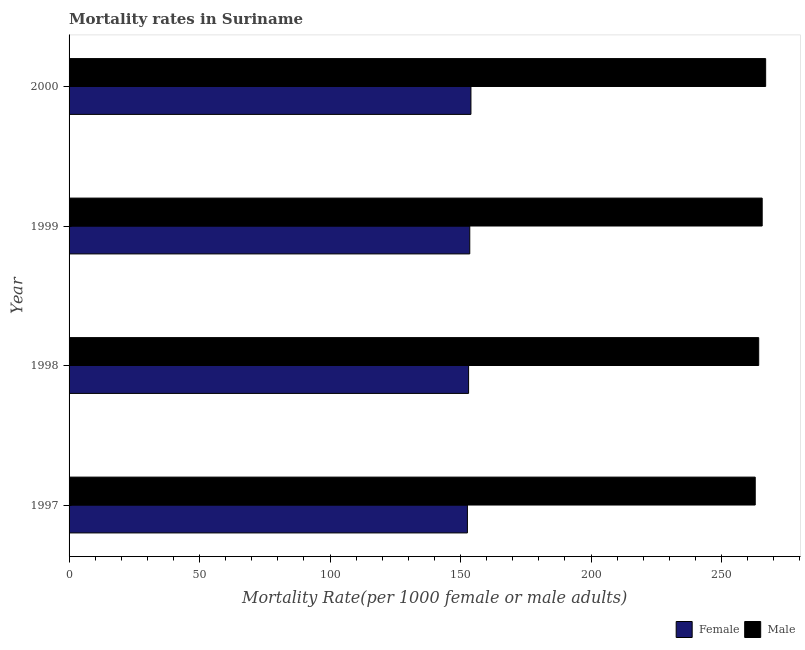How many different coloured bars are there?
Make the answer very short. 2. How many bars are there on the 1st tick from the bottom?
Give a very brief answer. 2. What is the female mortality rate in 1997?
Make the answer very short. 152.63. Across all years, what is the maximum male mortality rate?
Provide a succinct answer. 266.91. Across all years, what is the minimum male mortality rate?
Give a very brief answer. 262.92. In which year was the female mortality rate maximum?
Your answer should be compact. 2000. What is the total female mortality rate in the graph?
Offer a terse response. 613.24. What is the difference between the male mortality rate in 1997 and that in 2000?
Your response must be concise. -4. What is the difference between the female mortality rate in 1999 and the male mortality rate in 2000?
Give a very brief answer. -113.38. What is the average male mortality rate per year?
Your answer should be compact. 264.92. In the year 1999, what is the difference between the male mortality rate and female mortality rate?
Keep it short and to the point. 112.05. In how many years, is the male mortality rate greater than 260 ?
Offer a very short reply. 4. Is the difference between the male mortality rate in 1998 and 1999 greater than the difference between the female mortality rate in 1998 and 1999?
Your answer should be compact. No. What is the difference between the highest and the second highest female mortality rate?
Make the answer very short. 0.45. What is the difference between the highest and the lowest female mortality rate?
Your response must be concise. 1.35. What does the 1st bar from the top in 1999 represents?
Your response must be concise. Male. How many bars are there?
Offer a terse response. 8. What is the difference between two consecutive major ticks on the X-axis?
Offer a very short reply. 50. Are the values on the major ticks of X-axis written in scientific E-notation?
Give a very brief answer. No. Does the graph contain any zero values?
Keep it short and to the point. No. How are the legend labels stacked?
Offer a terse response. Horizontal. What is the title of the graph?
Your answer should be compact. Mortality rates in Suriname. What is the label or title of the X-axis?
Give a very brief answer. Mortality Rate(per 1000 female or male adults). What is the label or title of the Y-axis?
Ensure brevity in your answer.  Year. What is the Mortality Rate(per 1000 female or male adults) of Female in 1997?
Offer a very short reply. 152.63. What is the Mortality Rate(per 1000 female or male adults) in Male in 1997?
Give a very brief answer. 262.92. What is the Mortality Rate(per 1000 female or male adults) of Female in 1998?
Offer a terse response. 153.08. What is the Mortality Rate(per 1000 female or male adults) of Male in 1998?
Provide a short and direct response. 264.25. What is the Mortality Rate(per 1000 female or male adults) in Female in 1999?
Ensure brevity in your answer.  153.53. What is the Mortality Rate(per 1000 female or male adults) of Male in 1999?
Your answer should be very brief. 265.58. What is the Mortality Rate(per 1000 female or male adults) of Female in 2000?
Your answer should be compact. 153.99. What is the Mortality Rate(per 1000 female or male adults) of Male in 2000?
Keep it short and to the point. 266.91. Across all years, what is the maximum Mortality Rate(per 1000 female or male adults) in Female?
Your answer should be very brief. 153.99. Across all years, what is the maximum Mortality Rate(per 1000 female or male adults) of Male?
Make the answer very short. 266.91. Across all years, what is the minimum Mortality Rate(per 1000 female or male adults) in Female?
Provide a succinct answer. 152.63. Across all years, what is the minimum Mortality Rate(per 1000 female or male adults) of Male?
Your answer should be compact. 262.92. What is the total Mortality Rate(per 1000 female or male adults) of Female in the graph?
Your answer should be compact. 613.24. What is the total Mortality Rate(per 1000 female or male adults) in Male in the graph?
Your response must be concise. 1059.66. What is the difference between the Mortality Rate(per 1000 female or male adults) of Female in 1997 and that in 1998?
Your response must be concise. -0.45. What is the difference between the Mortality Rate(per 1000 female or male adults) of Male in 1997 and that in 1998?
Offer a very short reply. -1.33. What is the difference between the Mortality Rate(per 1000 female or male adults) of Female in 1997 and that in 1999?
Provide a succinct answer. -0.9. What is the difference between the Mortality Rate(per 1000 female or male adults) in Male in 1997 and that in 1999?
Offer a very short reply. -2.66. What is the difference between the Mortality Rate(per 1000 female or male adults) of Female in 1997 and that in 2000?
Offer a very short reply. -1.35. What is the difference between the Mortality Rate(per 1000 female or male adults) of Male in 1997 and that in 2000?
Offer a very short reply. -4. What is the difference between the Mortality Rate(per 1000 female or male adults) of Female in 1998 and that in 1999?
Keep it short and to the point. -0.45. What is the difference between the Mortality Rate(per 1000 female or male adults) in Male in 1998 and that in 1999?
Offer a terse response. -1.33. What is the difference between the Mortality Rate(per 1000 female or male adults) of Female in 1998 and that in 2000?
Give a very brief answer. -0.9. What is the difference between the Mortality Rate(per 1000 female or male adults) of Male in 1998 and that in 2000?
Provide a short and direct response. -2.66. What is the difference between the Mortality Rate(per 1000 female or male adults) in Female in 1999 and that in 2000?
Your response must be concise. -0.45. What is the difference between the Mortality Rate(per 1000 female or male adults) in Male in 1999 and that in 2000?
Provide a short and direct response. -1.33. What is the difference between the Mortality Rate(per 1000 female or male adults) in Female in 1997 and the Mortality Rate(per 1000 female or male adults) in Male in 1998?
Keep it short and to the point. -111.62. What is the difference between the Mortality Rate(per 1000 female or male adults) of Female in 1997 and the Mortality Rate(per 1000 female or male adults) of Male in 1999?
Offer a very short reply. -112.95. What is the difference between the Mortality Rate(per 1000 female or male adults) of Female in 1997 and the Mortality Rate(per 1000 female or male adults) of Male in 2000?
Provide a succinct answer. -114.28. What is the difference between the Mortality Rate(per 1000 female or male adults) of Female in 1998 and the Mortality Rate(per 1000 female or male adults) of Male in 1999?
Ensure brevity in your answer.  -112.5. What is the difference between the Mortality Rate(per 1000 female or male adults) in Female in 1998 and the Mortality Rate(per 1000 female or male adults) in Male in 2000?
Make the answer very short. -113.83. What is the difference between the Mortality Rate(per 1000 female or male adults) in Female in 1999 and the Mortality Rate(per 1000 female or male adults) in Male in 2000?
Your answer should be very brief. -113.38. What is the average Mortality Rate(per 1000 female or male adults) in Female per year?
Provide a short and direct response. 153.31. What is the average Mortality Rate(per 1000 female or male adults) of Male per year?
Your response must be concise. 264.92. In the year 1997, what is the difference between the Mortality Rate(per 1000 female or male adults) in Female and Mortality Rate(per 1000 female or male adults) in Male?
Keep it short and to the point. -110.28. In the year 1998, what is the difference between the Mortality Rate(per 1000 female or male adults) of Female and Mortality Rate(per 1000 female or male adults) of Male?
Your answer should be very brief. -111.17. In the year 1999, what is the difference between the Mortality Rate(per 1000 female or male adults) in Female and Mortality Rate(per 1000 female or male adults) in Male?
Your answer should be compact. -112.05. In the year 2000, what is the difference between the Mortality Rate(per 1000 female or male adults) in Female and Mortality Rate(per 1000 female or male adults) in Male?
Provide a succinct answer. -112.93. What is the ratio of the Mortality Rate(per 1000 female or male adults) of Female in 1997 to that in 1998?
Ensure brevity in your answer.  1. What is the ratio of the Mortality Rate(per 1000 female or male adults) in Female in 1998 to that in 1999?
Make the answer very short. 1. What is the ratio of the Mortality Rate(per 1000 female or male adults) of Female in 1998 to that in 2000?
Your response must be concise. 0.99. What is the ratio of the Mortality Rate(per 1000 female or male adults) of Male in 1998 to that in 2000?
Your answer should be compact. 0.99. What is the difference between the highest and the second highest Mortality Rate(per 1000 female or male adults) in Female?
Make the answer very short. 0.45. What is the difference between the highest and the second highest Mortality Rate(per 1000 female or male adults) of Male?
Make the answer very short. 1.33. What is the difference between the highest and the lowest Mortality Rate(per 1000 female or male adults) of Female?
Make the answer very short. 1.35. What is the difference between the highest and the lowest Mortality Rate(per 1000 female or male adults) in Male?
Keep it short and to the point. 4. 